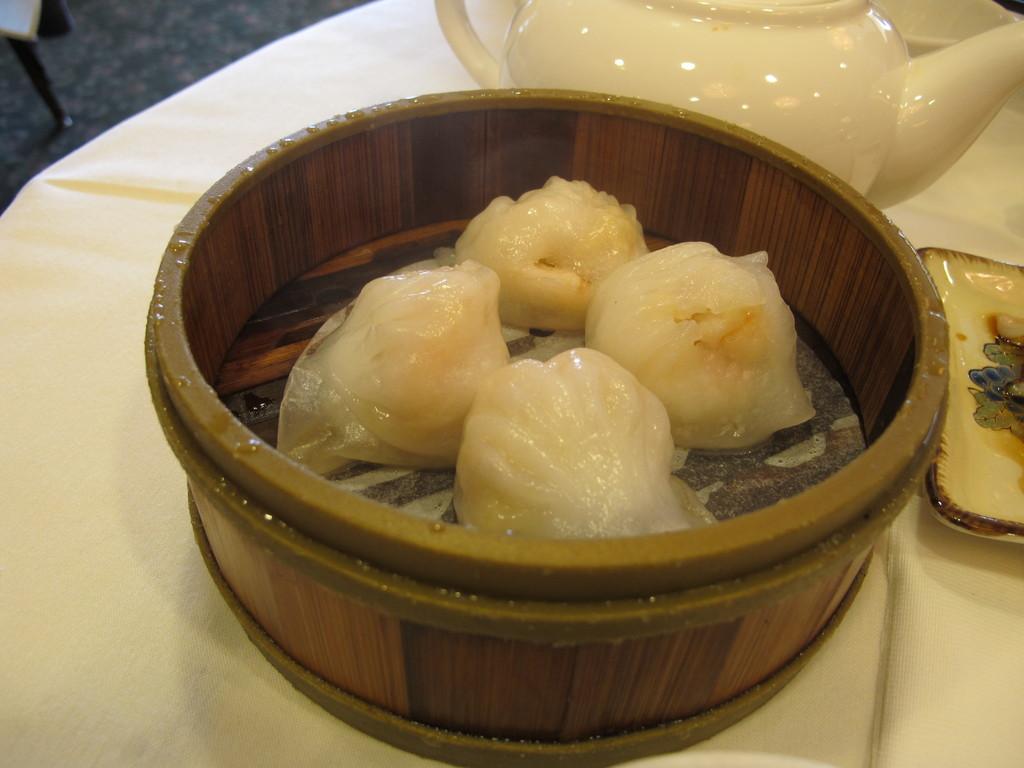Could you give a brief overview of what you see in this image? There are some momos present in a wooden bowl as we can see in the middle of this image. There is a teapot at the top of this image , and there is a tray as we can see on the right side of this image. All these are kept on a white color surface. It seems like there is a chair at the top left corner of this image. 